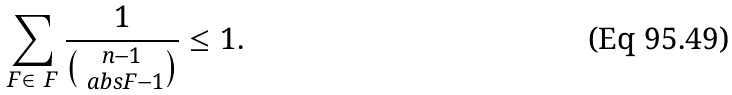<formula> <loc_0><loc_0><loc_500><loc_500>\sum _ { F \in \ F } \frac { 1 } { \binom { n - 1 } { \ a b s { F } - 1 } } \leq 1 .</formula> 